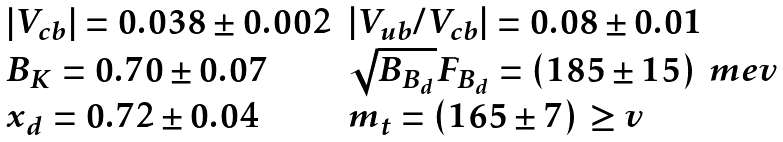<formula> <loc_0><loc_0><loc_500><loc_500>\begin{array} { l l } \left | V _ { c b } \right | = 0 . 0 3 8 \pm 0 . 0 0 2 & | V _ { u b } / V _ { c b } | = 0 . 0 8 \pm 0 . 0 1 \\ B _ { K } = 0 . 7 0 \pm 0 . 0 7 & \sqrt { B _ { B _ { d } } } F _ { B _ { d } } = ( 1 8 5 \pm 1 5 ) \, \ m e v \\ x _ { d } = 0 . 7 2 \pm 0 . 0 4 & m _ { t } = ( 1 6 5 \pm 7 ) \, \geq v \\ \end{array}</formula> 